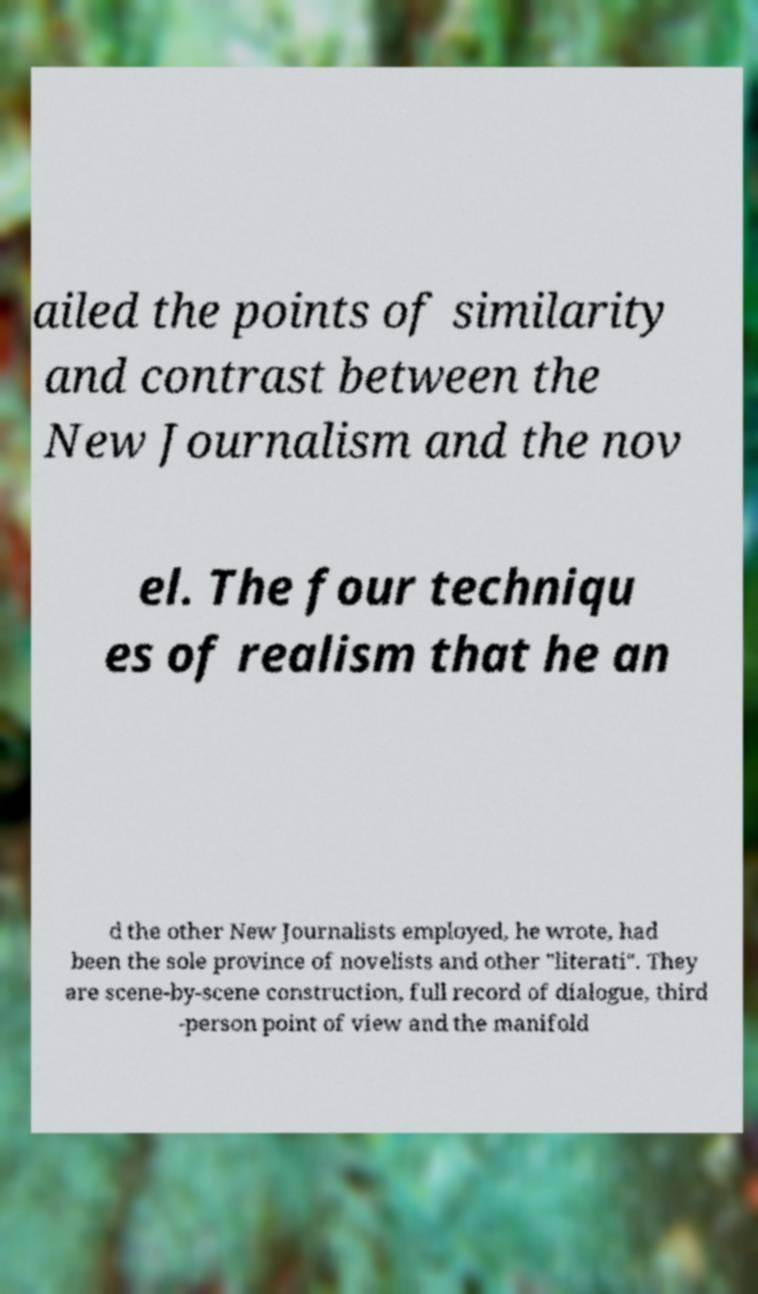Please read and relay the text visible in this image. What does it say? ailed the points of similarity and contrast between the New Journalism and the nov el. The four techniqu es of realism that he an d the other New Journalists employed, he wrote, had been the sole province of novelists and other "literati". They are scene-by-scene construction, full record of dialogue, third -person point of view and the manifold 